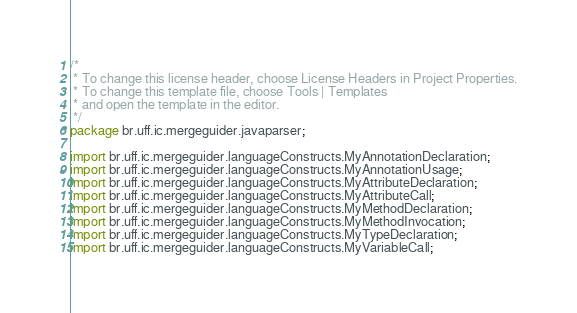Convert code to text. <code><loc_0><loc_0><loc_500><loc_500><_Java_>/*
 * To change this license header, choose License Headers in Project Properties.
 * To change this template file, choose Tools | Templates
 * and open the template in the editor.
 */
package br.uff.ic.mergeguider.javaparser;

import br.uff.ic.mergeguider.languageConstructs.MyAnnotationDeclaration;
import br.uff.ic.mergeguider.languageConstructs.MyAnnotationUsage;
import br.uff.ic.mergeguider.languageConstructs.MyAttributeDeclaration;
import br.uff.ic.mergeguider.languageConstructs.MyAttributeCall;
import br.uff.ic.mergeguider.languageConstructs.MyMethodDeclaration;
import br.uff.ic.mergeguider.languageConstructs.MyMethodInvocation;
import br.uff.ic.mergeguider.languageConstructs.MyTypeDeclaration;
import br.uff.ic.mergeguider.languageConstructs.MyVariableCall;</code> 